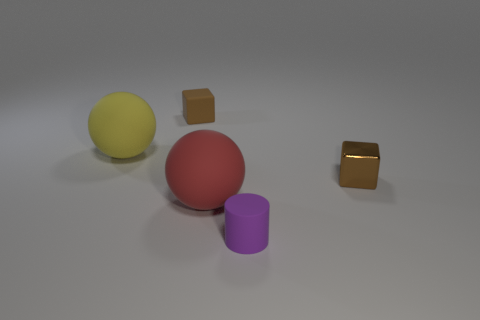There is a rubber sphere behind the small brown block that is right of the brown thing left of the small metal object; how big is it?
Ensure brevity in your answer.  Large. What color is the small object that is in front of the block that is to the right of the small purple matte thing?
Provide a succinct answer. Purple. What number of other things are there of the same material as the yellow object
Your response must be concise. 3. How many other objects are the same color as the small rubber cylinder?
Your answer should be very brief. 0. What is the material of the tiny brown block that is right of the object behind the yellow rubber thing?
Provide a short and direct response. Metal. Is there a small cube?
Your answer should be very brief. Yes. How big is the sphere that is behind the object right of the small purple matte cylinder?
Give a very brief answer. Large. Are there more big red things behind the small rubber cylinder than tiny brown matte things in front of the tiny matte cube?
Your answer should be compact. Yes. What number of balls are either small gray matte objects or large things?
Give a very brief answer. 2. There is a red rubber thing right of the matte block; does it have the same shape as the metal object?
Keep it short and to the point. No. 